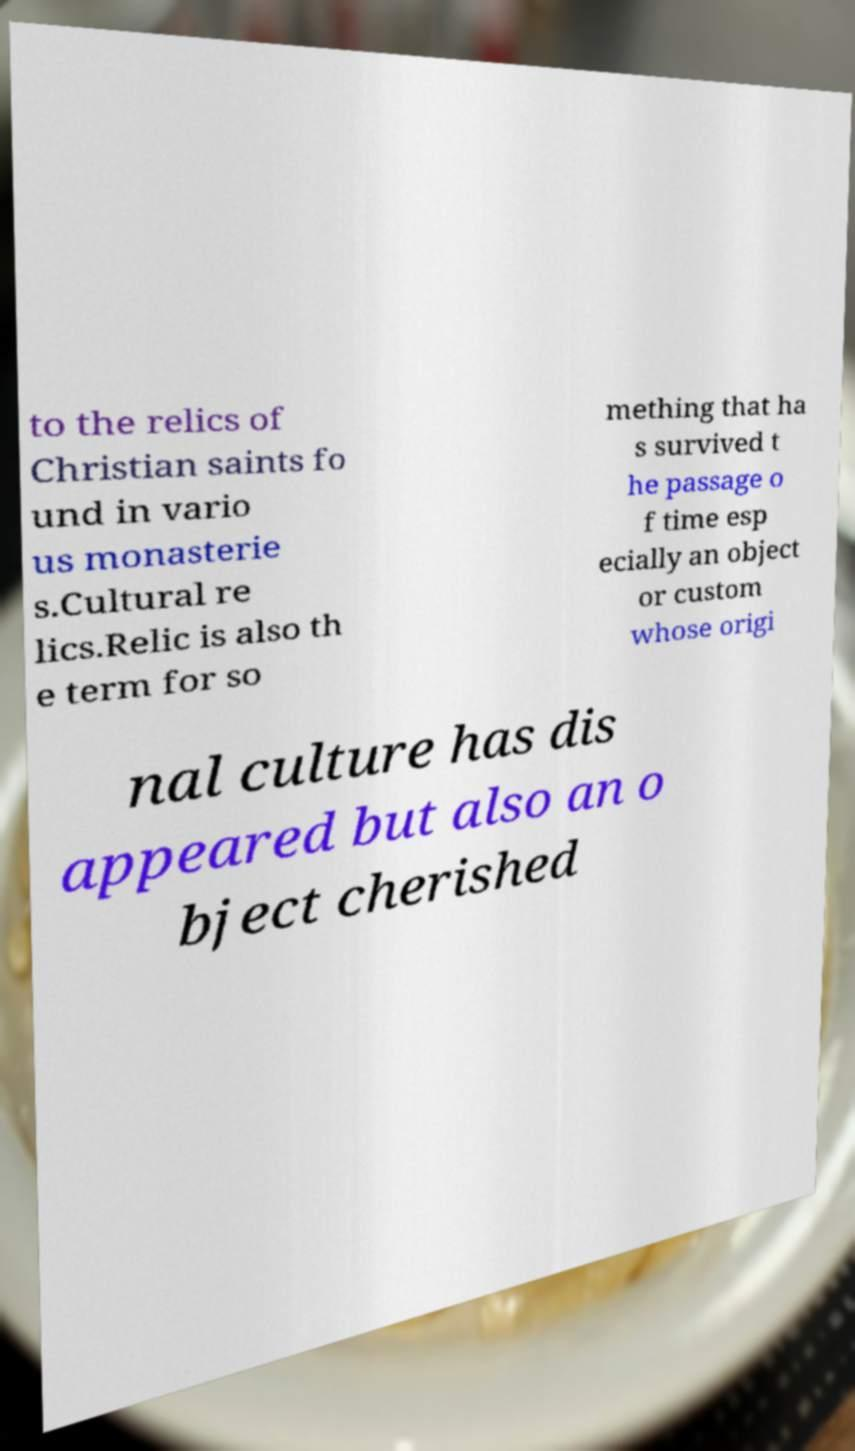Please read and relay the text visible in this image. What does it say? to the relics of Christian saints fo und in vario us monasterie s.Cultural re lics.Relic is also th e term for so mething that ha s survived t he passage o f time esp ecially an object or custom whose origi nal culture has dis appeared but also an o bject cherished 